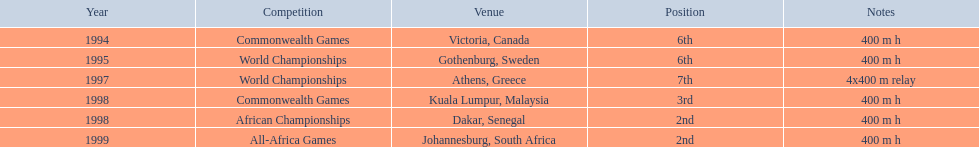Can you parse all the data within this table? {'header': ['Year', 'Competition', 'Venue', 'Position', 'Notes'], 'rows': [['1994', 'Commonwealth Games', 'Victoria, Canada', '6th', '400 m h'], ['1995', 'World Championships', 'Gothenburg, Sweden', '6th', '400 m h'], ['1997', 'World Championships', 'Athens, Greece', '7th', '4x400 m relay'], ['1998', 'Commonwealth Games', 'Kuala Lumpur, Malaysia', '3rd', '400 m h'], ['1998', 'African Championships', 'Dakar, Senegal', '2nd', '400 m h'], ['1999', 'All-Africa Games', 'Johannesburg, South Africa', '2nd', '400 m h']]} During which years did ken harder take part in competitions? 1994, 1995, 1997, 1998, 1998, 1999. What was the distance of the 1997 relay? 4x400 m relay. 